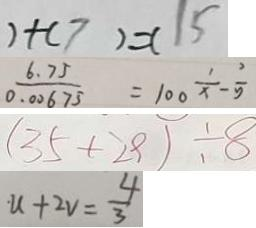<formula> <loc_0><loc_0><loc_500><loc_500>) + ( 7 ) = ( 1 5 
 \frac { 6 . 7 5 } { 0 . 0 0 6 7 5 } = 1 0 0 \frac { 1 } { x } - \frac { 2 } { 5 } 
 ( 3 5 + 2 9 ) \div 8 
 u + 2 v = \frac { 4 } { 3 }</formula> 